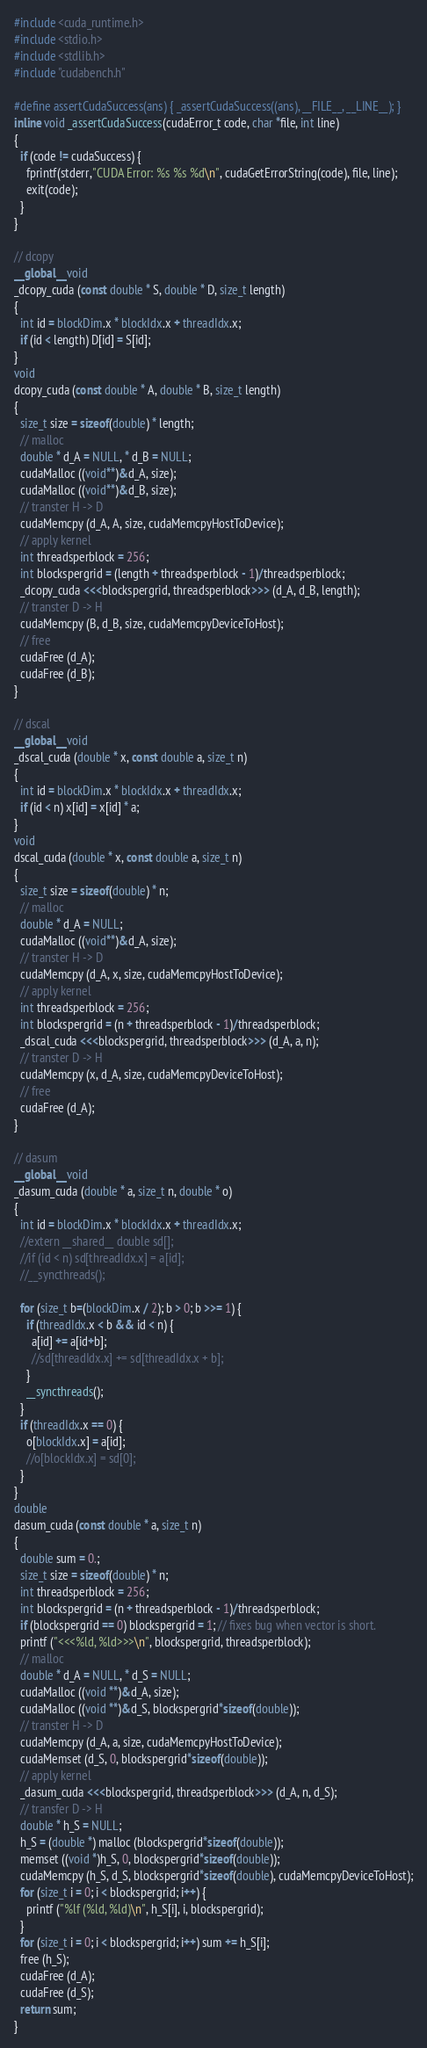Convert code to text. <code><loc_0><loc_0><loc_500><loc_500><_Cuda_>
#include <cuda_runtime.h>
#include <stdio.h>
#include <stdlib.h>
#include "cudabench.h"

#define assertCudaSuccess(ans) { _assertCudaSuccess((ans), __FILE__, __LINE__); }
inline void _assertCudaSuccess(cudaError_t code, char *file, int line)
{
  if (code != cudaSuccess) {
    fprintf(stderr,"CUDA Error: %s %s %d\n", cudaGetErrorString(code), file, line);
    exit(code);
  }
}

// dcopy
__global__ void
_dcopy_cuda (const double * S, double * D, size_t length)
{
  int id = blockDim.x * blockIdx.x + threadIdx.x;
  if (id < length) D[id] = S[id];
}
void
dcopy_cuda (const double * A, double * B, size_t length)
{
  size_t size = sizeof(double) * length;
  // malloc
  double * d_A = NULL, * d_B = NULL;
  cudaMalloc ((void**)&d_A, size);
  cudaMalloc ((void**)&d_B, size);
  // transter H -> D
  cudaMemcpy (d_A, A, size, cudaMemcpyHostToDevice);
  // apply kernel
  int threadsperblock = 256;
  int blockspergrid = (length + threadsperblock - 1)/threadsperblock;
  _dcopy_cuda <<<blockspergrid, threadsperblock>>> (d_A, d_B, length);
  // transter D -> H
  cudaMemcpy (B, d_B, size, cudaMemcpyDeviceToHost);
  // free
  cudaFree (d_A);
  cudaFree (d_B);
}

// dscal
__global__ void
_dscal_cuda (double * x, const double a, size_t n)
{
  int id = blockDim.x * blockIdx.x + threadIdx.x;
  if (id < n) x[id] = x[id] * a;
}
void
dscal_cuda (double * x, const double a, size_t n)
{
  size_t size = sizeof(double) * n;
  // malloc
  double * d_A = NULL;
  cudaMalloc ((void**)&d_A, size);
  // transter H -> D
  cudaMemcpy (d_A, x, size, cudaMemcpyHostToDevice);
  // apply kernel
  int threadsperblock = 256;
  int blockspergrid = (n + threadsperblock - 1)/threadsperblock;
  _dscal_cuda <<<blockspergrid, threadsperblock>>> (d_A, a, n);
  // transter D -> H
  cudaMemcpy (x, d_A, size, cudaMemcpyDeviceToHost);
  // free
  cudaFree (d_A);
}

// dasum
__global__ void
_dasum_cuda (double * a, size_t n, double * o)
{
  int id = blockDim.x * blockIdx.x + threadIdx.x;
  //extern __shared__ double sd[];
  //if (id < n) sd[threadIdx.x] = a[id];
  //__syncthreads();

  for (size_t b=(blockDim.x / 2); b > 0; b >>= 1) {
    if (threadIdx.x < b && id < n) {
      a[id] += a[id+b];
      //sd[threadIdx.x] += sd[threadIdx.x + b];
    }
    __syncthreads();
  }
  if (threadIdx.x == 0) {
    o[blockIdx.x] = a[id];
    //o[blockIdx.x] = sd[0];
  }
}
double
dasum_cuda (const double * a, size_t n)
{
  double sum = 0.;
  size_t size = sizeof(double) * n;
  int threadsperblock = 256;
  int blockspergrid = (n + threadsperblock - 1)/threadsperblock;
  if (blockspergrid == 0) blockspergrid = 1; // fixes bug when vector is short.
  printf ("<<<%ld, %ld>>>\n", blockspergrid, threadsperblock);
  // malloc
  double * d_A = NULL, * d_S = NULL;
  cudaMalloc ((void **)&d_A, size);
  cudaMalloc ((void **)&d_S, blockspergrid*sizeof(double));
  // transter H -> D
  cudaMemcpy (d_A, a, size, cudaMemcpyHostToDevice);
  cudaMemset (d_S, 0, blockspergrid*sizeof(double));
  // apply kernel
  _dasum_cuda <<<blockspergrid, threadsperblock>>> (d_A, n, d_S);
  // transfer D -> H
  double * h_S = NULL;
  h_S = (double *) malloc (blockspergrid*sizeof(double));
  memset ((void *)h_S, 0, blockspergrid*sizeof(double));
  cudaMemcpy (h_S, d_S, blockspergrid*sizeof(double), cudaMemcpyDeviceToHost);
  for (size_t i = 0; i < blockspergrid; i++) {
    printf ("%lf (%ld, %ld)\n", h_S[i], i, blockspergrid);
  }
  for (size_t i = 0; i < blockspergrid; i++) sum += h_S[i];
  free (h_S);
  cudaFree (d_A);
  cudaFree (d_S);
  return sum;
}
</code> 